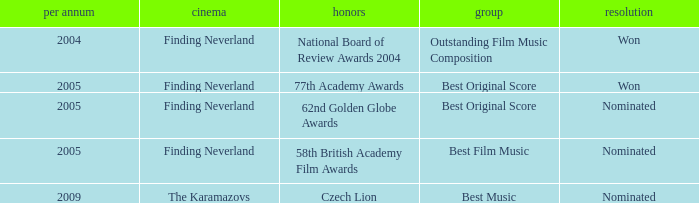Which awards happened more recently than 2005? Czech Lion. 